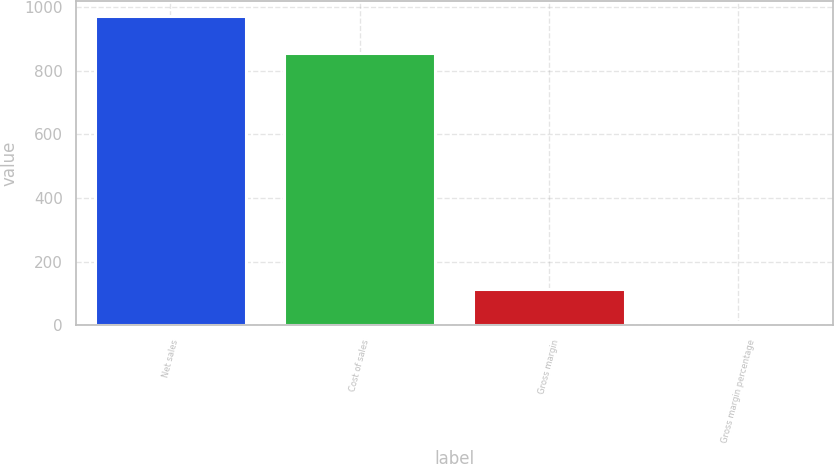Convert chart to OTSL. <chart><loc_0><loc_0><loc_500><loc_500><bar_chart><fcel>Net sales<fcel>Cost of sales<fcel>Gross margin<fcel>Gross margin percentage<nl><fcel>971<fcel>856<fcel>115<fcel>11.8<nl></chart> 